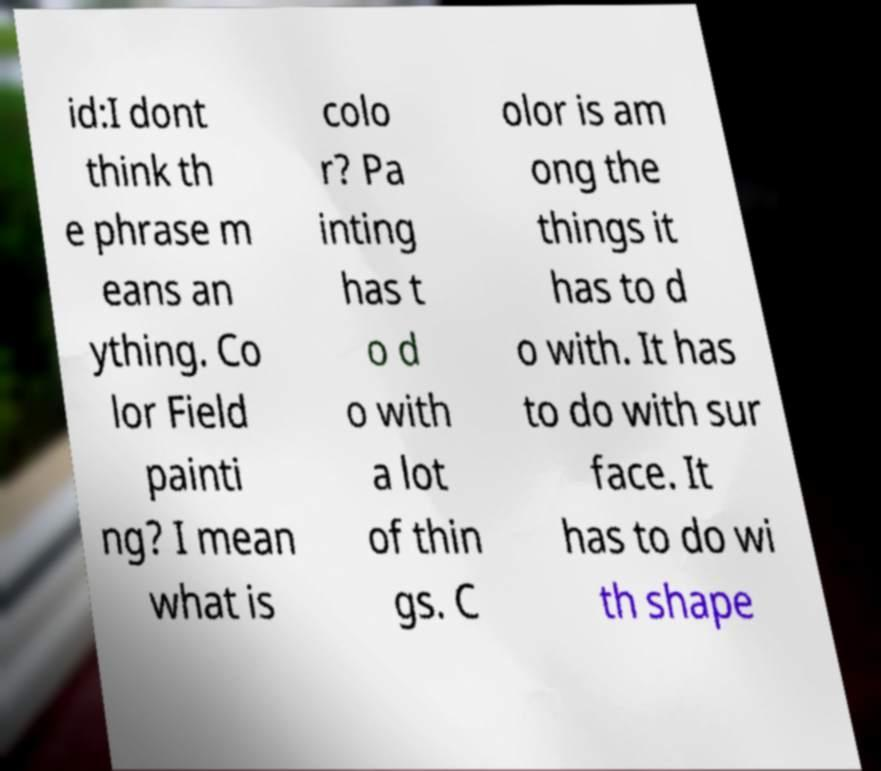For documentation purposes, I need the text within this image transcribed. Could you provide that? id:I dont think th e phrase m eans an ything. Co lor Field painti ng? I mean what is colo r? Pa inting has t o d o with a lot of thin gs. C olor is am ong the things it has to d o with. It has to do with sur face. It has to do wi th shape 